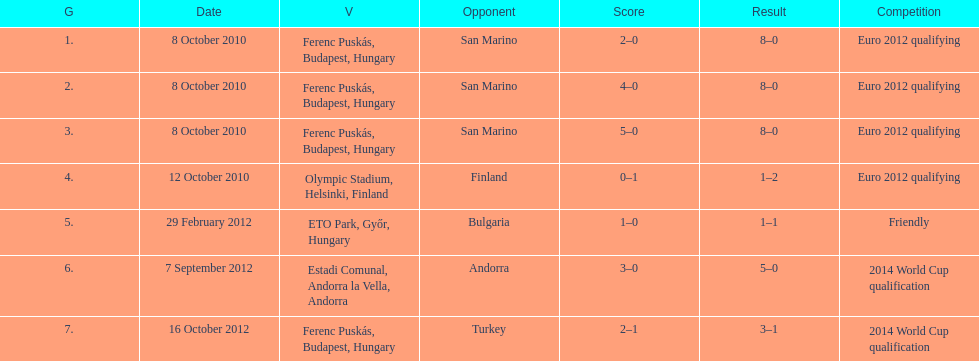When did ádám szalai make his first international goal? 8 October 2010. 